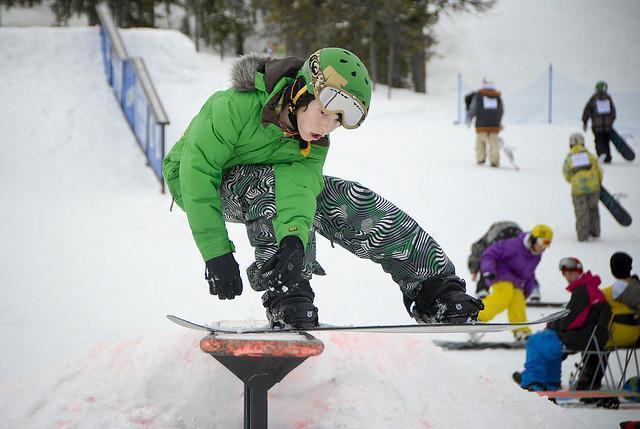Who watches these people while they board on snow?
Indicate the correct choice and explain in the format: 'Answer: answer
Rationale: rationale.'
Options: Judges, coal miners, no one, enemies. Answer: judges.
Rationale: The snow boarders walking up the slope have numbers on their backs. numbers are used for competitions. 